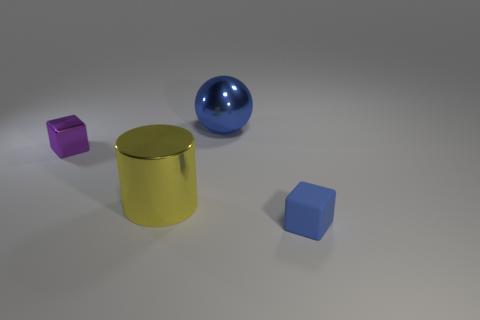Subtract all gray balls. Subtract all gray cylinders. How many balls are left? 1 Add 3 big yellow metal things. How many objects exist? 7 Subtract all cylinders. How many objects are left? 3 Add 3 small blue rubber cubes. How many small blue rubber cubes exist? 4 Subtract 1 yellow cylinders. How many objects are left? 3 Subtract all purple metal cubes. Subtract all blue matte objects. How many objects are left? 2 Add 3 yellow cylinders. How many yellow cylinders are left? 4 